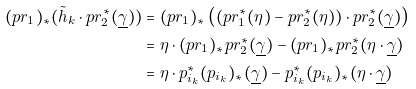Convert formula to latex. <formula><loc_0><loc_0><loc_500><loc_500>( p r _ { 1 } ) _ { * } ( \tilde { h } _ { k } \cdot p r _ { 2 } ^ { * } ( \underline { \gamma } ) ) & = ( p r _ { 1 } ) _ { * } \left ( ( p r _ { 1 } ^ { * } ( \eta ) - p r _ { 2 } ^ { * } ( \eta ) ) \cdot p r _ { 2 } ^ { * } ( \underline { \gamma } ) \right ) \\ & = \eta \cdot ( p r _ { 1 } ) _ { * } p r _ { 2 } ^ { * } ( \underline { \gamma } ) - ( p r _ { 1 } ) _ { * } p r _ { 2 } ^ { * } ( \eta \cdot \underline { \gamma } ) \\ & = \eta \cdot p _ { i _ { k } } ^ { * } ( p _ { i _ { k } } ) _ { * } ( \underline { \gamma } ) - p _ { i _ { k } } ^ { * } ( p _ { i _ { k } } ) _ { * } ( \eta \cdot \underline { \gamma } )</formula> 